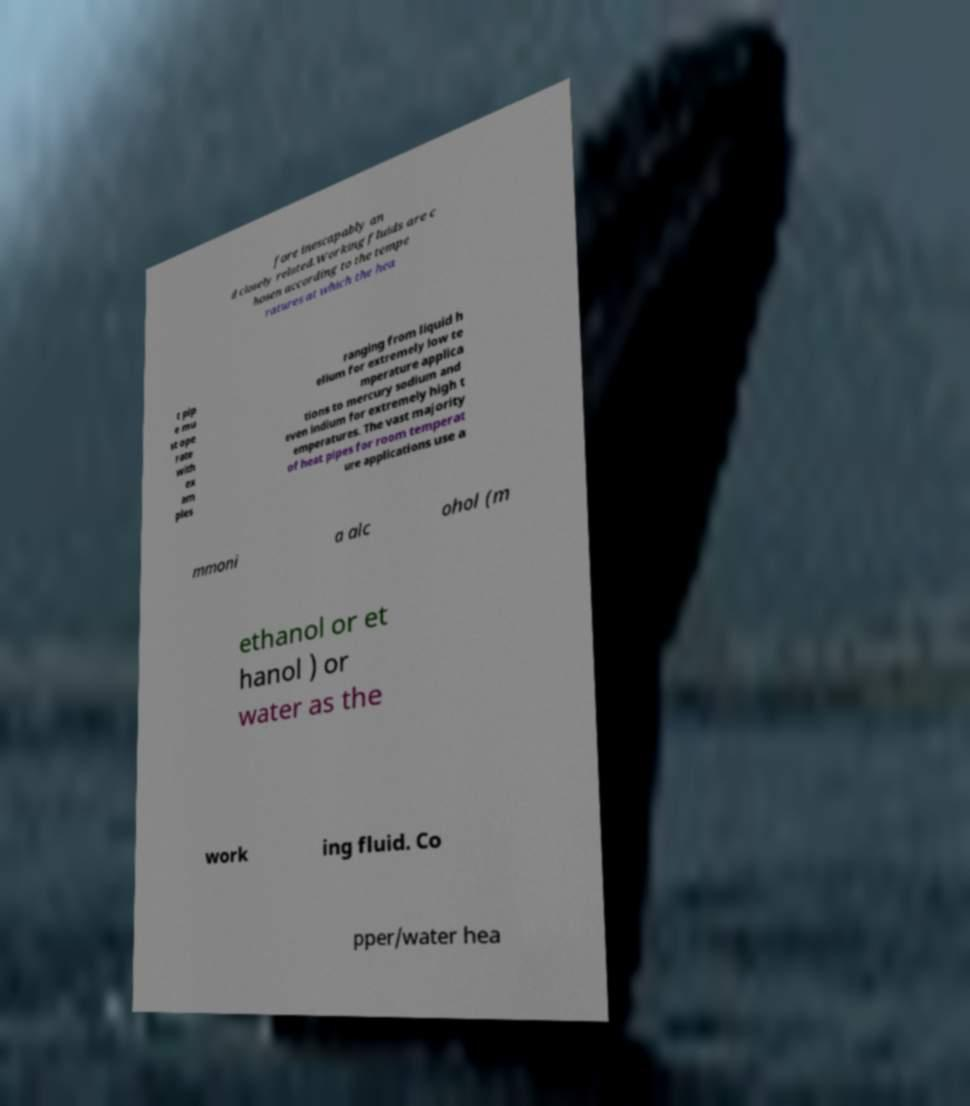Could you assist in decoding the text presented in this image and type it out clearly? fore inescapably an d closely related.Working fluids are c hosen according to the tempe ratures at which the hea t pip e mu st ope rate with ex am ples ranging from liquid h elium for extremely low te mperature applica tions to mercury sodium and even indium for extremely high t emperatures. The vast majority of heat pipes for room temperat ure applications use a mmoni a alc ohol (m ethanol or et hanol ) or water as the work ing fluid. Co pper/water hea 